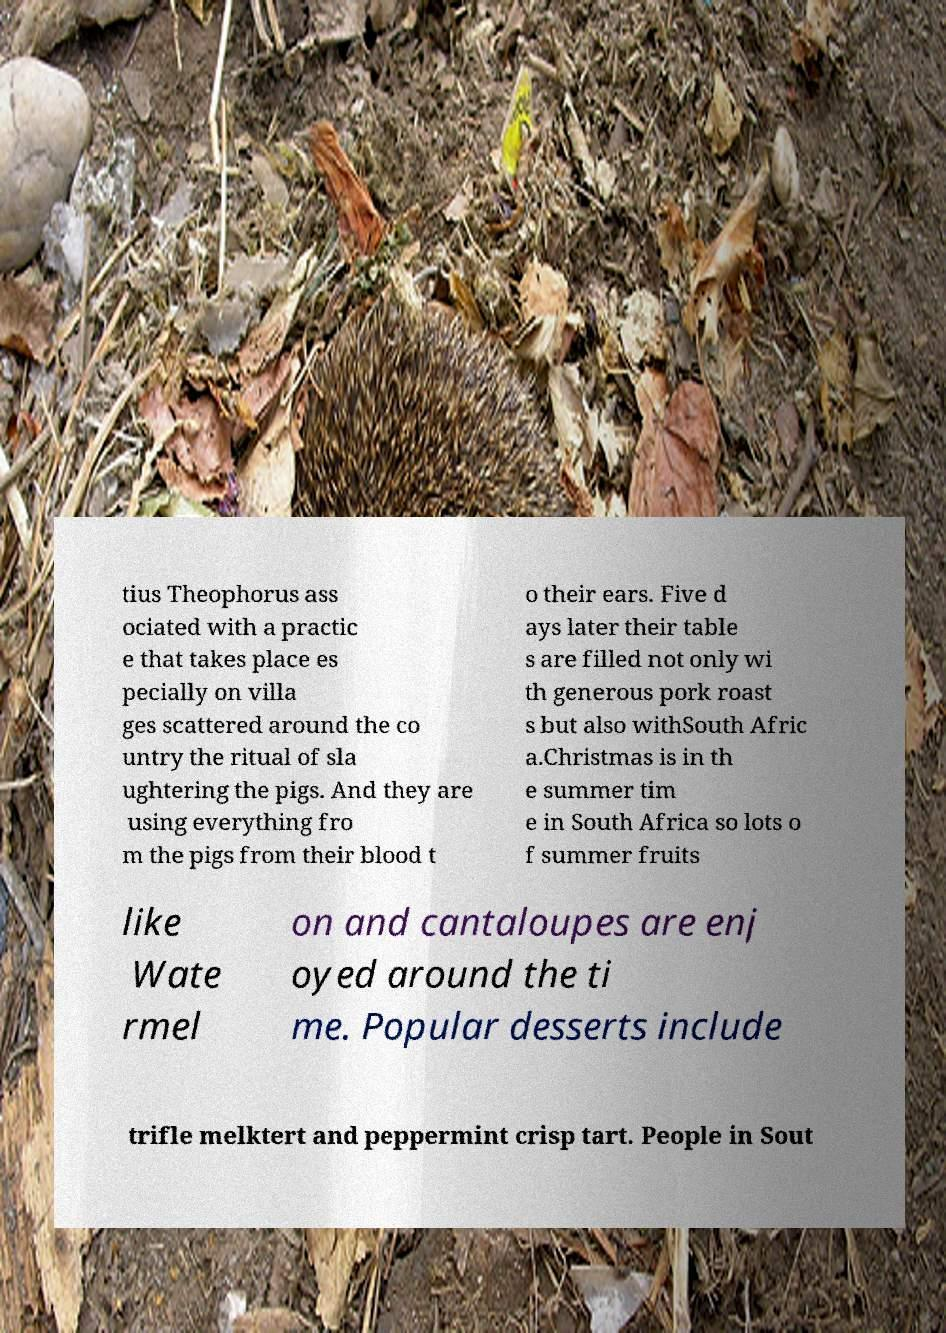Can you accurately transcribe the text from the provided image for me? tius Theophorus ass ociated with a practic e that takes place es pecially on villa ges scattered around the co untry the ritual of sla ughtering the pigs. And they are using everything fro m the pigs from their blood t o their ears. Five d ays later their table s are filled not only wi th generous pork roast s but also withSouth Afric a.Christmas is in th e summer tim e in South Africa so lots o f summer fruits like Wate rmel on and cantaloupes are enj oyed around the ti me. Popular desserts include trifle melktert and peppermint crisp tart. People in Sout 